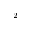<formula> <loc_0><loc_0><loc_500><loc_500>^ { 2 }</formula> 